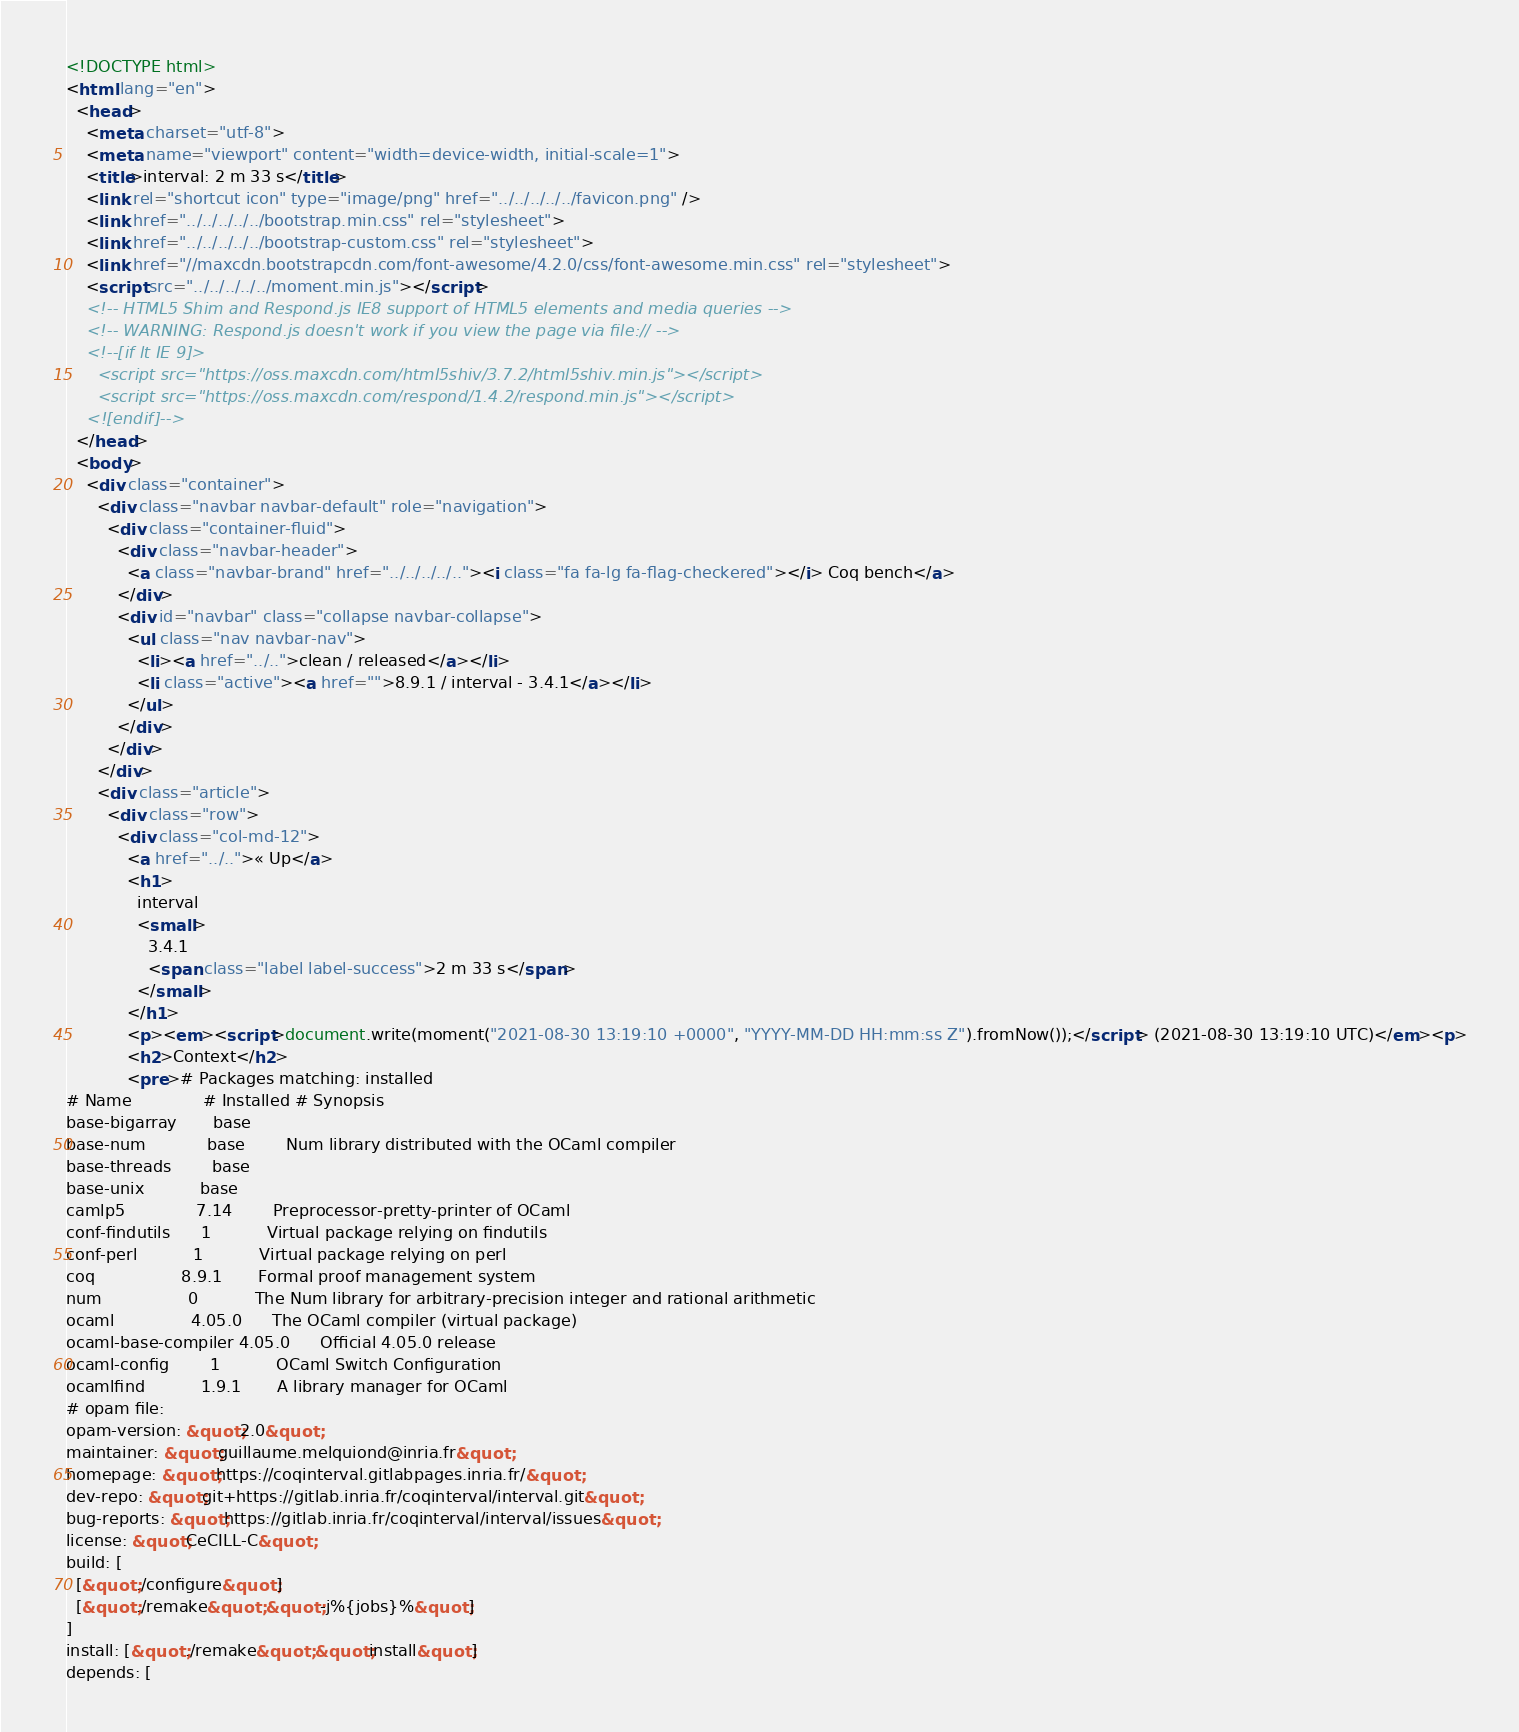Convert code to text. <code><loc_0><loc_0><loc_500><loc_500><_HTML_><!DOCTYPE html>
<html lang="en">
  <head>
    <meta charset="utf-8">
    <meta name="viewport" content="width=device-width, initial-scale=1">
    <title>interval: 2 m 33 s</title>
    <link rel="shortcut icon" type="image/png" href="../../../../../favicon.png" />
    <link href="../../../../../bootstrap.min.css" rel="stylesheet">
    <link href="../../../../../bootstrap-custom.css" rel="stylesheet">
    <link href="//maxcdn.bootstrapcdn.com/font-awesome/4.2.0/css/font-awesome.min.css" rel="stylesheet">
    <script src="../../../../../moment.min.js"></script>
    <!-- HTML5 Shim and Respond.js IE8 support of HTML5 elements and media queries -->
    <!-- WARNING: Respond.js doesn't work if you view the page via file:// -->
    <!--[if lt IE 9]>
      <script src="https://oss.maxcdn.com/html5shiv/3.7.2/html5shiv.min.js"></script>
      <script src="https://oss.maxcdn.com/respond/1.4.2/respond.min.js"></script>
    <![endif]-->
  </head>
  <body>
    <div class="container">
      <div class="navbar navbar-default" role="navigation">
        <div class="container-fluid">
          <div class="navbar-header">
            <a class="navbar-brand" href="../../../../.."><i class="fa fa-lg fa-flag-checkered"></i> Coq bench</a>
          </div>
          <div id="navbar" class="collapse navbar-collapse">
            <ul class="nav navbar-nav">
              <li><a href="../..">clean / released</a></li>
              <li class="active"><a href="">8.9.1 / interval - 3.4.1</a></li>
            </ul>
          </div>
        </div>
      </div>
      <div class="article">
        <div class="row">
          <div class="col-md-12">
            <a href="../..">« Up</a>
            <h1>
              interval
              <small>
                3.4.1
                <span class="label label-success">2 m 33 s</span>
              </small>
            </h1>
            <p><em><script>document.write(moment("2021-08-30 13:19:10 +0000", "YYYY-MM-DD HH:mm:ss Z").fromNow());</script> (2021-08-30 13:19:10 UTC)</em><p>
            <h2>Context</h2>
            <pre># Packages matching: installed
# Name              # Installed # Synopsis
base-bigarray       base
base-num            base        Num library distributed with the OCaml compiler
base-threads        base
base-unix           base
camlp5              7.14        Preprocessor-pretty-printer of OCaml
conf-findutils      1           Virtual package relying on findutils
conf-perl           1           Virtual package relying on perl
coq                 8.9.1       Formal proof management system
num                 0           The Num library for arbitrary-precision integer and rational arithmetic
ocaml               4.05.0      The OCaml compiler (virtual package)
ocaml-base-compiler 4.05.0      Official 4.05.0 release
ocaml-config        1           OCaml Switch Configuration
ocamlfind           1.9.1       A library manager for OCaml
# opam file:
opam-version: &quot;2.0&quot;
maintainer: &quot;guillaume.melquiond@inria.fr&quot;
homepage: &quot;https://coqinterval.gitlabpages.inria.fr/&quot;
dev-repo: &quot;git+https://gitlab.inria.fr/coqinterval/interval.git&quot;
bug-reports: &quot;https://gitlab.inria.fr/coqinterval/interval/issues&quot;
license: &quot;CeCILL-C&quot;
build: [
  [&quot;./configure&quot;]
  [&quot;./remake&quot; &quot;-j%{jobs}%&quot;]
]
install: [&quot;./remake&quot; &quot;install&quot;]
depends: [</code> 